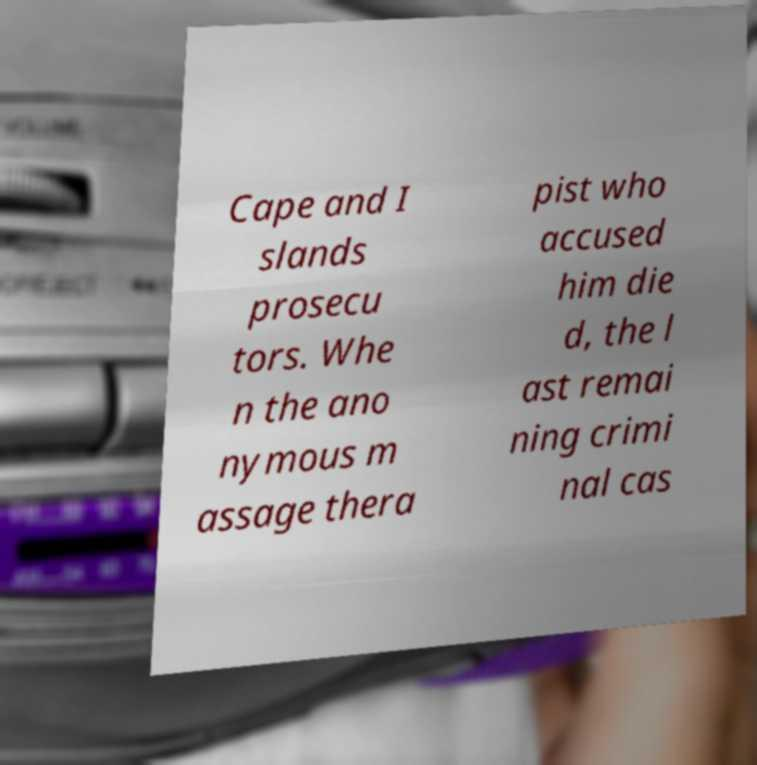Could you extract and type out the text from this image? Cape and I slands prosecu tors. Whe n the ano nymous m assage thera pist who accused him die d, the l ast remai ning crimi nal cas 